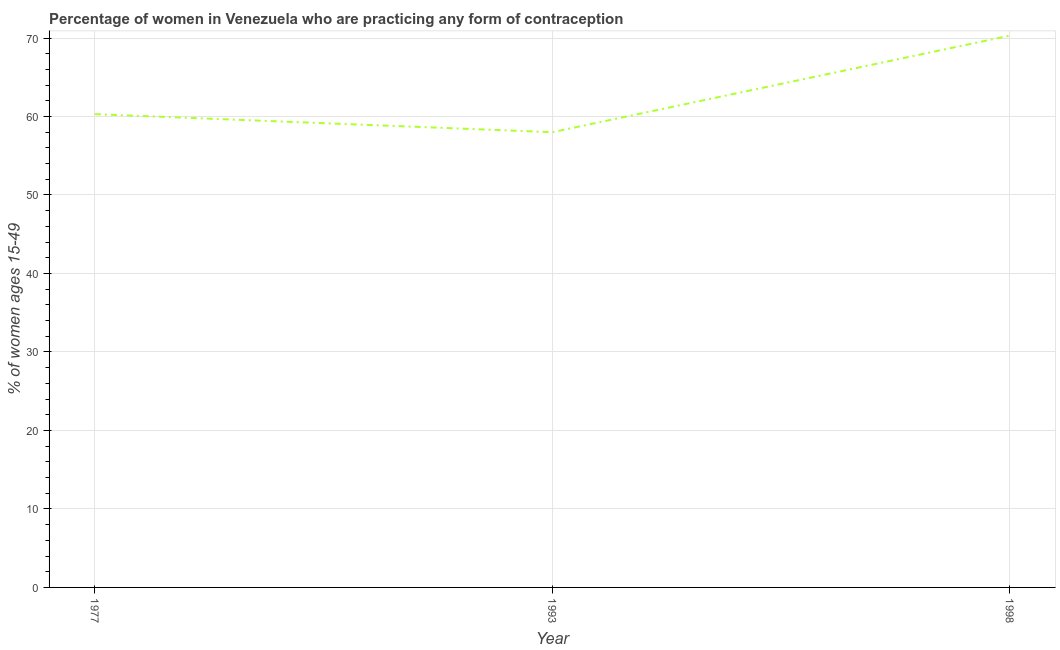Across all years, what is the maximum contraceptive prevalence?
Your response must be concise. 70.3. Across all years, what is the minimum contraceptive prevalence?
Ensure brevity in your answer.  58. In which year was the contraceptive prevalence maximum?
Provide a succinct answer. 1998. What is the sum of the contraceptive prevalence?
Give a very brief answer. 188.6. What is the difference between the contraceptive prevalence in 1977 and 1998?
Provide a succinct answer. -10. What is the average contraceptive prevalence per year?
Your answer should be very brief. 62.87. What is the median contraceptive prevalence?
Ensure brevity in your answer.  60.3. What is the ratio of the contraceptive prevalence in 1977 to that in 1993?
Offer a very short reply. 1.04. Is the difference between the contraceptive prevalence in 1993 and 1998 greater than the difference between any two years?
Offer a terse response. Yes. What is the difference between the highest and the second highest contraceptive prevalence?
Your response must be concise. 10. Is the sum of the contraceptive prevalence in 1977 and 1998 greater than the maximum contraceptive prevalence across all years?
Offer a terse response. Yes. What is the difference between the highest and the lowest contraceptive prevalence?
Offer a very short reply. 12.3. In how many years, is the contraceptive prevalence greater than the average contraceptive prevalence taken over all years?
Provide a succinct answer. 1. How many lines are there?
Provide a short and direct response. 1. How many years are there in the graph?
Provide a short and direct response. 3. What is the difference between two consecutive major ticks on the Y-axis?
Make the answer very short. 10. Are the values on the major ticks of Y-axis written in scientific E-notation?
Provide a short and direct response. No. Does the graph contain any zero values?
Provide a short and direct response. No. What is the title of the graph?
Offer a very short reply. Percentage of women in Venezuela who are practicing any form of contraception. What is the label or title of the X-axis?
Your answer should be very brief. Year. What is the label or title of the Y-axis?
Your response must be concise. % of women ages 15-49. What is the % of women ages 15-49 in 1977?
Offer a terse response. 60.3. What is the % of women ages 15-49 in 1993?
Keep it short and to the point. 58. What is the % of women ages 15-49 of 1998?
Provide a short and direct response. 70.3. What is the difference between the % of women ages 15-49 in 1977 and 1993?
Provide a succinct answer. 2.3. What is the ratio of the % of women ages 15-49 in 1977 to that in 1998?
Make the answer very short. 0.86. What is the ratio of the % of women ages 15-49 in 1993 to that in 1998?
Your answer should be compact. 0.82. 